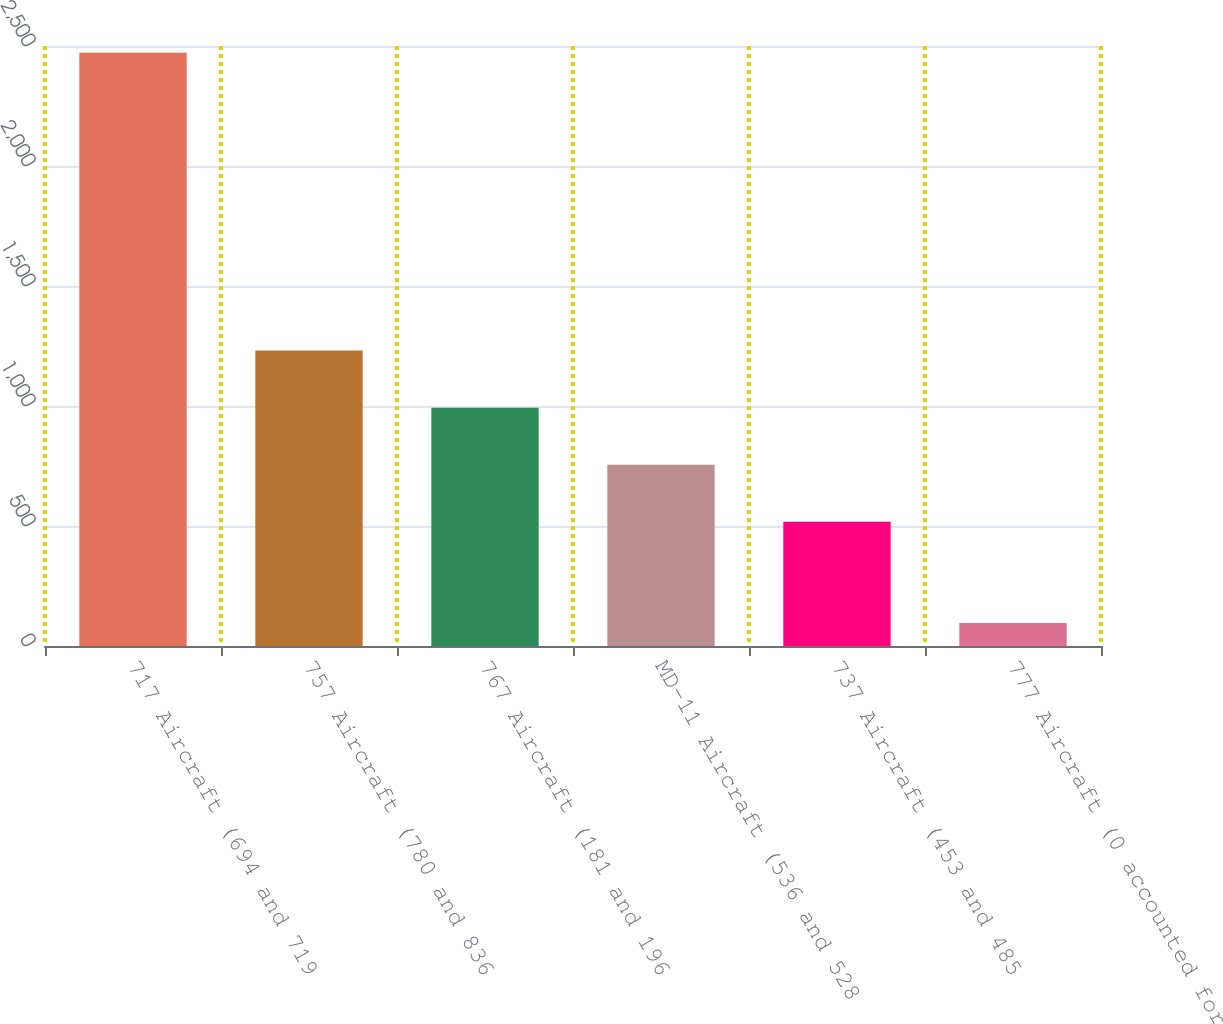<chart> <loc_0><loc_0><loc_500><loc_500><bar_chart><fcel>717 Aircraft (694 and 719<fcel>757 Aircraft (780 and 836<fcel>767 Aircraft (181 and 196<fcel>MD-11 Aircraft (536 and 528<fcel>737 Aircraft (453 and 485<fcel>777 Aircraft (0 accounted for<nl><fcel>2472<fcel>1230.8<fcel>993.2<fcel>755.6<fcel>518<fcel>96<nl></chart> 